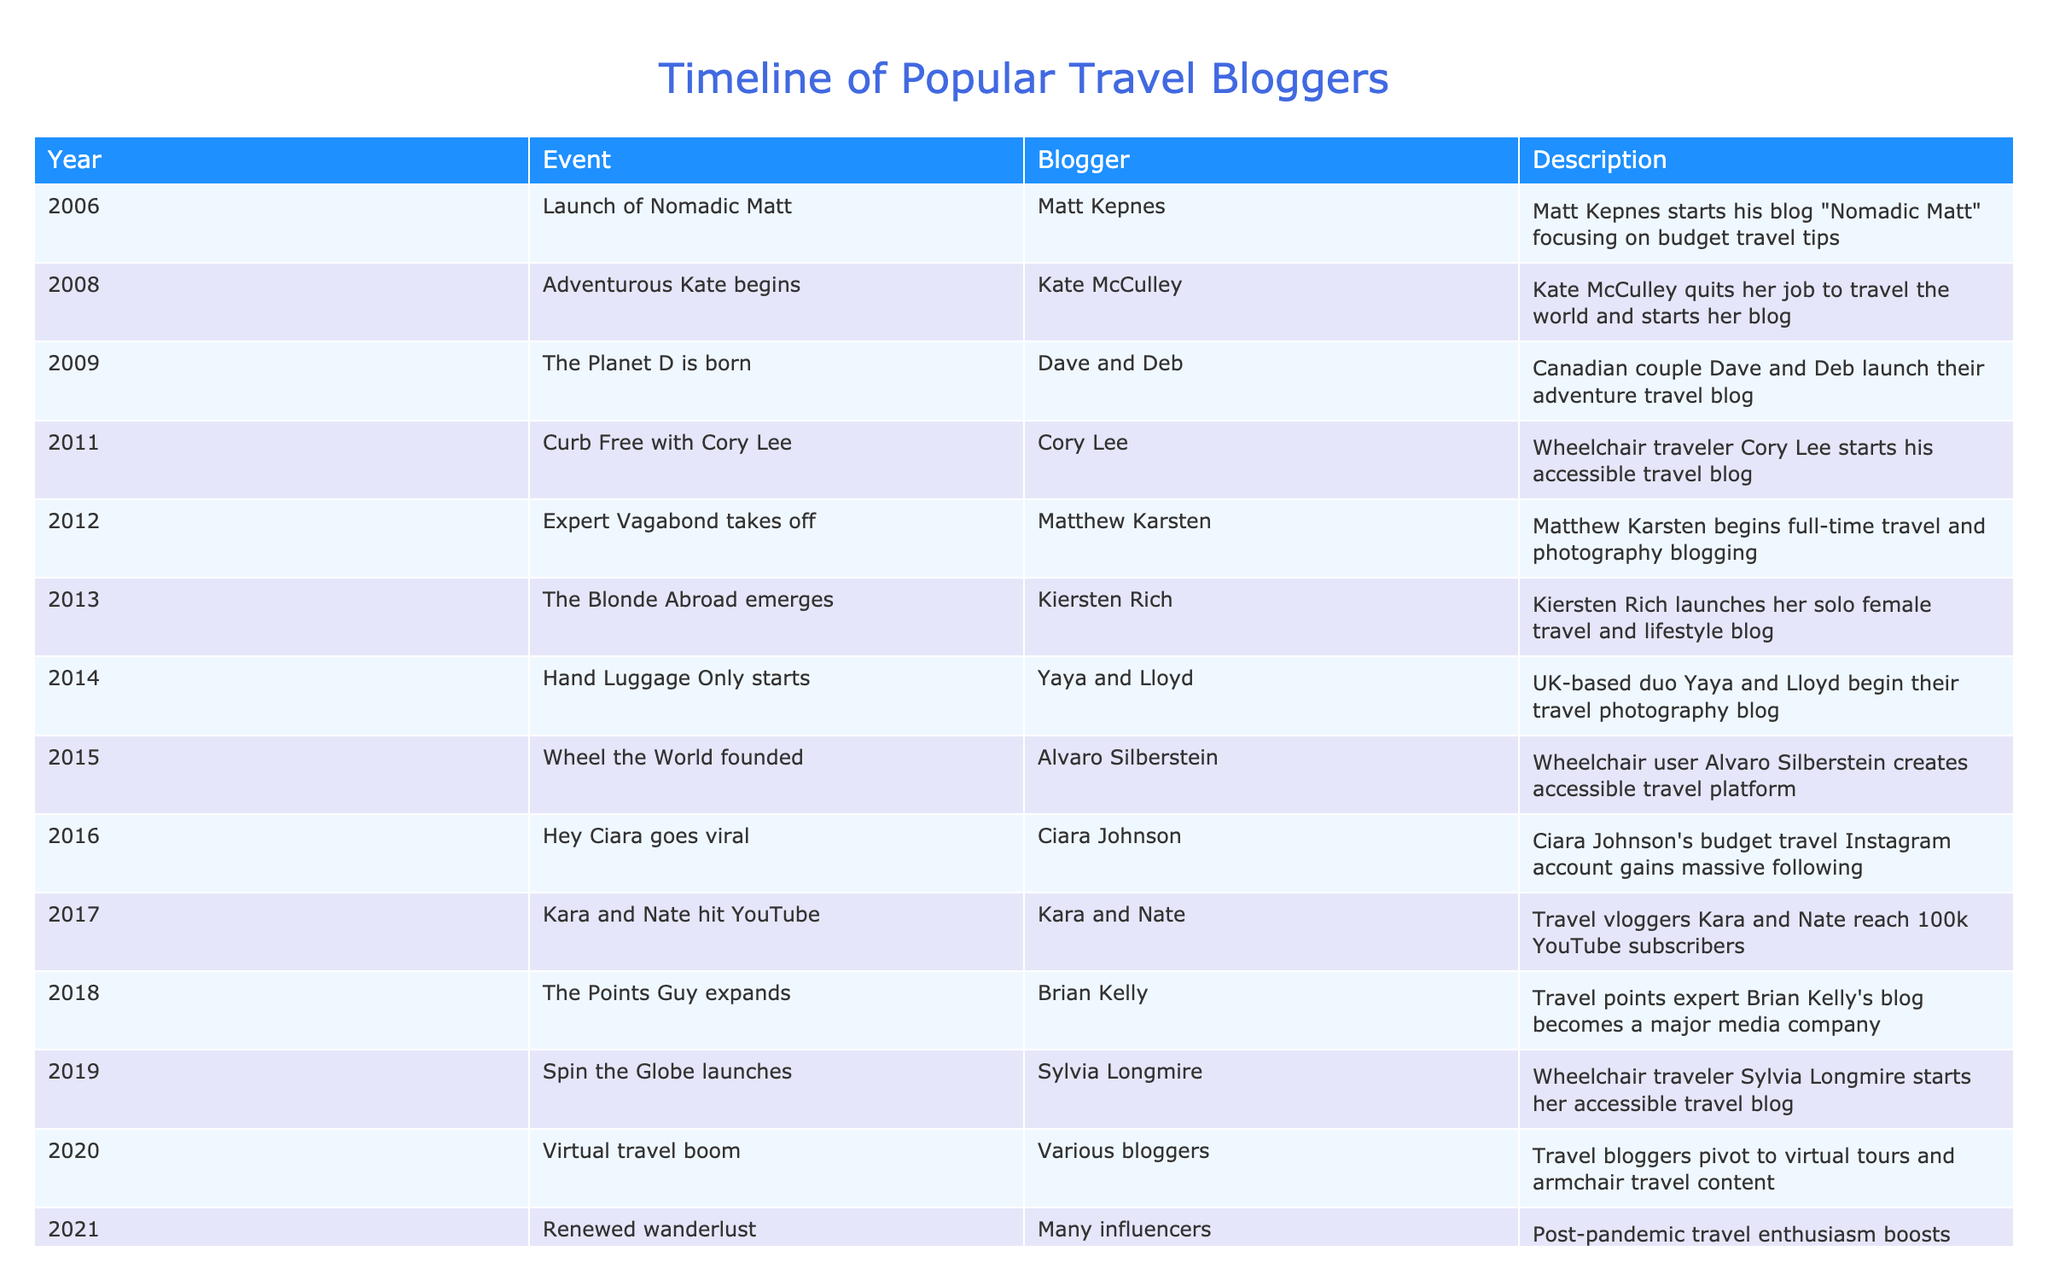What year did Matt Kepnes launch his blog? Referring to the table, the launch year of "Nomadic Matt" by Matt Kepnes is listed as 2006.
Answer: 2006 Which blogger quit their job to travel full-time? The table indicates that Kate McCulley, under the event "Adventurous Kate begins" in 2008, is the one who quit her job to travel the world.
Answer: Kate McCulley How many years passed between the launches of Nomadic Matt and The Planet D? "Nomadic Matt" was launched in 2006 and "The Planet D" in 2009. The difference between 2009 and 2006 is 3 years.
Answer: 3 years Was there any significant travel blogging activity in 2020? The table states that various bloggers pivoted to virtual tours and armchair travel content in 2020, indicating significant activity in that year. Therefore, the answer is yes.
Answer: Yes List all bloggers who started their blogs related to accessible travel. From the table, the bloggers who focused on accessible travel are Cory Lee (2011) and Sylvia Longmire (2019). Both created blogs specifically dedicated to accessibility in travel.
Answer: Cory Lee and Sylvia Longmire What is the year difference between the launches of Accessible Travel Day and the founding of Wheel the World? Accessible Travel Day (2022) and Wheel the World (2015), the difference is 7 years since 2022 minus 2015 equals 7.
Answer: 7 years Which event involved multiple bloggers promoting accessible travel influencers? Based on the table, the event listed as "Accessible Travel Day" in 2022 involved multiple bloggers promoting accessible travel influencers.
Answer: Accessible Travel Day Who were the first and last bloggers mentioned in the timeline? The first blogger mentioned is Matt Kepnes with the launch of "Nomadic Matt" in 2006 and the last is multiple bloggers related to "Accessible Travel Day" in 2022.
Answer: Matt Kepnes and multiple bloggers What percentage of bloggers in this timeline specifically focus on accessible travel? Out of 15 total events, 3 are related to accessible travel (Cory Lee in 2011, Alvaro Silberstein in 2015, and Sylvia Longmire in 2019). Thus, (3/15) * 100 = 20%.
Answer: 20% 